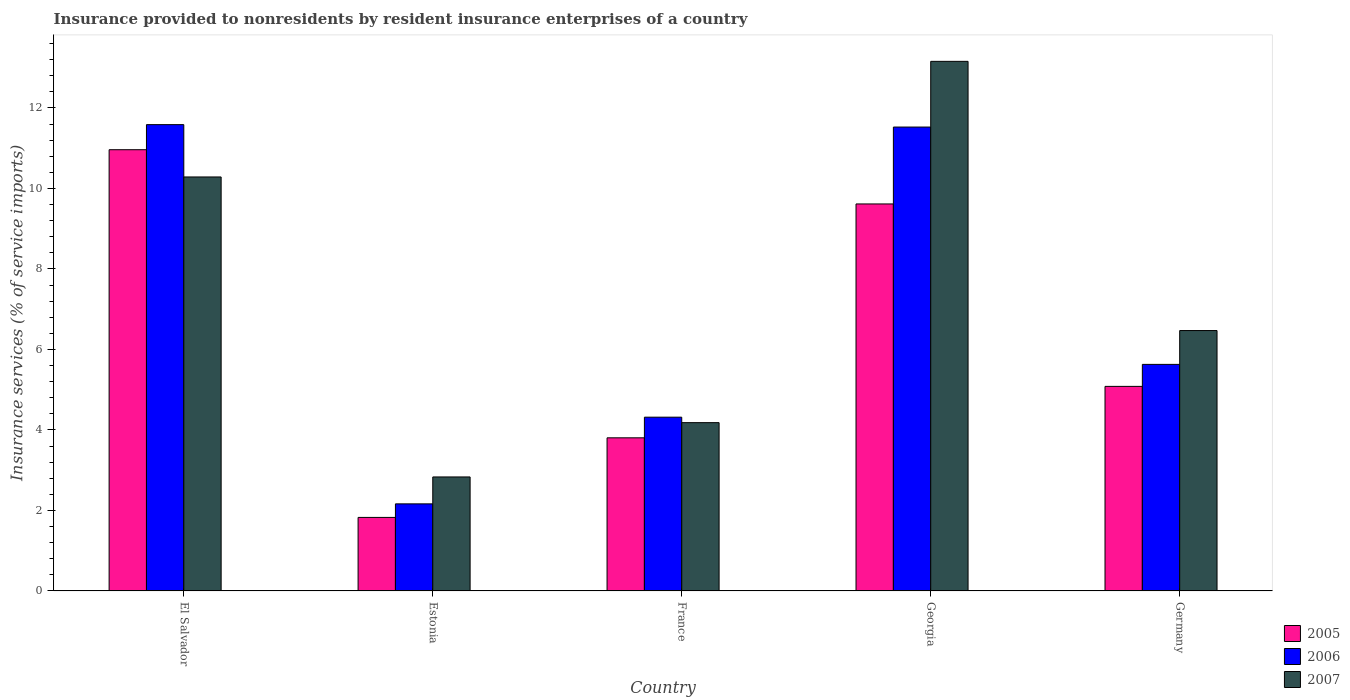Are the number of bars on each tick of the X-axis equal?
Offer a terse response. Yes. How many bars are there on the 4th tick from the left?
Your answer should be compact. 3. What is the label of the 4th group of bars from the left?
Your answer should be very brief. Georgia. What is the insurance provided to nonresidents in 2006 in Estonia?
Offer a very short reply. 2.16. Across all countries, what is the maximum insurance provided to nonresidents in 2006?
Provide a succinct answer. 11.59. Across all countries, what is the minimum insurance provided to nonresidents in 2005?
Your response must be concise. 1.83. In which country was the insurance provided to nonresidents in 2007 maximum?
Provide a succinct answer. Georgia. In which country was the insurance provided to nonresidents in 2006 minimum?
Your answer should be compact. Estonia. What is the total insurance provided to nonresidents in 2007 in the graph?
Provide a short and direct response. 36.93. What is the difference between the insurance provided to nonresidents in 2006 in Georgia and that in Germany?
Offer a terse response. 5.9. What is the difference between the insurance provided to nonresidents in 2007 in Estonia and the insurance provided to nonresidents in 2005 in Germany?
Give a very brief answer. -2.25. What is the average insurance provided to nonresidents in 2006 per country?
Ensure brevity in your answer.  7.04. What is the difference between the insurance provided to nonresidents of/in 2006 and insurance provided to nonresidents of/in 2005 in Germany?
Offer a terse response. 0.55. In how many countries, is the insurance provided to nonresidents in 2007 greater than 12.8 %?
Keep it short and to the point. 1. What is the ratio of the insurance provided to nonresidents in 2005 in Estonia to that in Germany?
Offer a terse response. 0.36. Is the insurance provided to nonresidents in 2005 in Georgia less than that in Germany?
Offer a very short reply. No. What is the difference between the highest and the second highest insurance provided to nonresidents in 2007?
Offer a very short reply. -2.87. What is the difference between the highest and the lowest insurance provided to nonresidents in 2007?
Your answer should be very brief. 10.32. Is the sum of the insurance provided to nonresidents in 2007 in Estonia and Georgia greater than the maximum insurance provided to nonresidents in 2006 across all countries?
Give a very brief answer. Yes. Is it the case that in every country, the sum of the insurance provided to nonresidents in 2007 and insurance provided to nonresidents in 2006 is greater than the insurance provided to nonresidents in 2005?
Provide a short and direct response. Yes. How many countries are there in the graph?
Your answer should be very brief. 5. What is the difference between two consecutive major ticks on the Y-axis?
Provide a short and direct response. 2. Are the values on the major ticks of Y-axis written in scientific E-notation?
Ensure brevity in your answer.  No. Does the graph contain any zero values?
Your answer should be compact. No. Where does the legend appear in the graph?
Provide a short and direct response. Bottom right. How many legend labels are there?
Make the answer very short. 3. What is the title of the graph?
Offer a very short reply. Insurance provided to nonresidents by resident insurance enterprises of a country. Does "1962" appear as one of the legend labels in the graph?
Make the answer very short. No. What is the label or title of the X-axis?
Your answer should be compact. Country. What is the label or title of the Y-axis?
Give a very brief answer. Insurance services (% of service imports). What is the Insurance services (% of service imports) of 2005 in El Salvador?
Offer a terse response. 10.96. What is the Insurance services (% of service imports) in 2006 in El Salvador?
Provide a succinct answer. 11.59. What is the Insurance services (% of service imports) of 2007 in El Salvador?
Ensure brevity in your answer.  10.29. What is the Insurance services (% of service imports) of 2005 in Estonia?
Provide a succinct answer. 1.83. What is the Insurance services (% of service imports) in 2006 in Estonia?
Offer a very short reply. 2.16. What is the Insurance services (% of service imports) in 2007 in Estonia?
Your answer should be compact. 2.83. What is the Insurance services (% of service imports) of 2005 in France?
Provide a short and direct response. 3.81. What is the Insurance services (% of service imports) of 2006 in France?
Your answer should be very brief. 4.32. What is the Insurance services (% of service imports) in 2007 in France?
Your response must be concise. 4.18. What is the Insurance services (% of service imports) in 2005 in Georgia?
Provide a succinct answer. 9.62. What is the Insurance services (% of service imports) of 2006 in Georgia?
Keep it short and to the point. 11.53. What is the Insurance services (% of service imports) of 2007 in Georgia?
Offer a very short reply. 13.16. What is the Insurance services (% of service imports) of 2005 in Germany?
Provide a short and direct response. 5.08. What is the Insurance services (% of service imports) of 2006 in Germany?
Provide a short and direct response. 5.63. What is the Insurance services (% of service imports) of 2007 in Germany?
Ensure brevity in your answer.  6.47. Across all countries, what is the maximum Insurance services (% of service imports) in 2005?
Provide a short and direct response. 10.96. Across all countries, what is the maximum Insurance services (% of service imports) in 2006?
Offer a very short reply. 11.59. Across all countries, what is the maximum Insurance services (% of service imports) of 2007?
Offer a very short reply. 13.16. Across all countries, what is the minimum Insurance services (% of service imports) of 2005?
Your response must be concise. 1.83. Across all countries, what is the minimum Insurance services (% of service imports) of 2006?
Your response must be concise. 2.16. Across all countries, what is the minimum Insurance services (% of service imports) of 2007?
Keep it short and to the point. 2.83. What is the total Insurance services (% of service imports) in 2005 in the graph?
Provide a succinct answer. 31.29. What is the total Insurance services (% of service imports) of 2006 in the graph?
Keep it short and to the point. 35.22. What is the total Insurance services (% of service imports) in 2007 in the graph?
Keep it short and to the point. 36.93. What is the difference between the Insurance services (% of service imports) in 2005 in El Salvador and that in Estonia?
Make the answer very short. 9.13. What is the difference between the Insurance services (% of service imports) of 2006 in El Salvador and that in Estonia?
Your answer should be compact. 9.42. What is the difference between the Insurance services (% of service imports) of 2007 in El Salvador and that in Estonia?
Provide a succinct answer. 7.45. What is the difference between the Insurance services (% of service imports) in 2005 in El Salvador and that in France?
Give a very brief answer. 7.16. What is the difference between the Insurance services (% of service imports) of 2006 in El Salvador and that in France?
Your answer should be very brief. 7.27. What is the difference between the Insurance services (% of service imports) of 2007 in El Salvador and that in France?
Your response must be concise. 6.1. What is the difference between the Insurance services (% of service imports) in 2005 in El Salvador and that in Georgia?
Offer a very short reply. 1.35. What is the difference between the Insurance services (% of service imports) of 2006 in El Salvador and that in Georgia?
Your answer should be compact. 0.06. What is the difference between the Insurance services (% of service imports) of 2007 in El Salvador and that in Georgia?
Keep it short and to the point. -2.87. What is the difference between the Insurance services (% of service imports) of 2005 in El Salvador and that in Germany?
Your answer should be very brief. 5.88. What is the difference between the Insurance services (% of service imports) in 2006 in El Salvador and that in Germany?
Keep it short and to the point. 5.96. What is the difference between the Insurance services (% of service imports) of 2007 in El Salvador and that in Germany?
Your response must be concise. 3.82. What is the difference between the Insurance services (% of service imports) in 2005 in Estonia and that in France?
Provide a short and direct response. -1.98. What is the difference between the Insurance services (% of service imports) in 2006 in Estonia and that in France?
Give a very brief answer. -2.15. What is the difference between the Insurance services (% of service imports) in 2007 in Estonia and that in France?
Make the answer very short. -1.35. What is the difference between the Insurance services (% of service imports) of 2005 in Estonia and that in Georgia?
Make the answer very short. -7.79. What is the difference between the Insurance services (% of service imports) in 2006 in Estonia and that in Georgia?
Make the answer very short. -9.36. What is the difference between the Insurance services (% of service imports) of 2007 in Estonia and that in Georgia?
Your response must be concise. -10.32. What is the difference between the Insurance services (% of service imports) in 2005 in Estonia and that in Germany?
Offer a very short reply. -3.25. What is the difference between the Insurance services (% of service imports) in 2006 in Estonia and that in Germany?
Your answer should be very brief. -3.47. What is the difference between the Insurance services (% of service imports) of 2007 in Estonia and that in Germany?
Keep it short and to the point. -3.64. What is the difference between the Insurance services (% of service imports) of 2005 in France and that in Georgia?
Offer a terse response. -5.81. What is the difference between the Insurance services (% of service imports) in 2006 in France and that in Georgia?
Keep it short and to the point. -7.21. What is the difference between the Insurance services (% of service imports) of 2007 in France and that in Georgia?
Make the answer very short. -8.98. What is the difference between the Insurance services (% of service imports) of 2005 in France and that in Germany?
Your answer should be very brief. -1.28. What is the difference between the Insurance services (% of service imports) in 2006 in France and that in Germany?
Provide a succinct answer. -1.31. What is the difference between the Insurance services (% of service imports) in 2007 in France and that in Germany?
Give a very brief answer. -2.29. What is the difference between the Insurance services (% of service imports) in 2005 in Georgia and that in Germany?
Provide a short and direct response. 4.53. What is the difference between the Insurance services (% of service imports) of 2006 in Georgia and that in Germany?
Keep it short and to the point. 5.9. What is the difference between the Insurance services (% of service imports) of 2007 in Georgia and that in Germany?
Provide a succinct answer. 6.69. What is the difference between the Insurance services (% of service imports) of 2005 in El Salvador and the Insurance services (% of service imports) of 2006 in Estonia?
Your answer should be very brief. 8.8. What is the difference between the Insurance services (% of service imports) in 2005 in El Salvador and the Insurance services (% of service imports) in 2007 in Estonia?
Offer a very short reply. 8.13. What is the difference between the Insurance services (% of service imports) of 2006 in El Salvador and the Insurance services (% of service imports) of 2007 in Estonia?
Keep it short and to the point. 8.75. What is the difference between the Insurance services (% of service imports) of 2005 in El Salvador and the Insurance services (% of service imports) of 2006 in France?
Ensure brevity in your answer.  6.64. What is the difference between the Insurance services (% of service imports) in 2005 in El Salvador and the Insurance services (% of service imports) in 2007 in France?
Offer a terse response. 6.78. What is the difference between the Insurance services (% of service imports) of 2006 in El Salvador and the Insurance services (% of service imports) of 2007 in France?
Provide a short and direct response. 7.4. What is the difference between the Insurance services (% of service imports) of 2005 in El Salvador and the Insurance services (% of service imports) of 2006 in Georgia?
Provide a succinct answer. -0.56. What is the difference between the Insurance services (% of service imports) in 2005 in El Salvador and the Insurance services (% of service imports) in 2007 in Georgia?
Offer a very short reply. -2.2. What is the difference between the Insurance services (% of service imports) of 2006 in El Salvador and the Insurance services (% of service imports) of 2007 in Georgia?
Your answer should be very brief. -1.57. What is the difference between the Insurance services (% of service imports) of 2005 in El Salvador and the Insurance services (% of service imports) of 2006 in Germany?
Offer a very short reply. 5.33. What is the difference between the Insurance services (% of service imports) of 2005 in El Salvador and the Insurance services (% of service imports) of 2007 in Germany?
Your answer should be compact. 4.49. What is the difference between the Insurance services (% of service imports) of 2006 in El Salvador and the Insurance services (% of service imports) of 2007 in Germany?
Ensure brevity in your answer.  5.12. What is the difference between the Insurance services (% of service imports) in 2005 in Estonia and the Insurance services (% of service imports) in 2006 in France?
Your response must be concise. -2.49. What is the difference between the Insurance services (% of service imports) of 2005 in Estonia and the Insurance services (% of service imports) of 2007 in France?
Offer a very short reply. -2.35. What is the difference between the Insurance services (% of service imports) of 2006 in Estonia and the Insurance services (% of service imports) of 2007 in France?
Provide a short and direct response. -2.02. What is the difference between the Insurance services (% of service imports) in 2005 in Estonia and the Insurance services (% of service imports) in 2006 in Georgia?
Offer a terse response. -9.7. What is the difference between the Insurance services (% of service imports) in 2005 in Estonia and the Insurance services (% of service imports) in 2007 in Georgia?
Keep it short and to the point. -11.33. What is the difference between the Insurance services (% of service imports) in 2006 in Estonia and the Insurance services (% of service imports) in 2007 in Georgia?
Your answer should be compact. -10.99. What is the difference between the Insurance services (% of service imports) in 2005 in Estonia and the Insurance services (% of service imports) in 2006 in Germany?
Your answer should be very brief. -3.8. What is the difference between the Insurance services (% of service imports) in 2005 in Estonia and the Insurance services (% of service imports) in 2007 in Germany?
Provide a succinct answer. -4.64. What is the difference between the Insurance services (% of service imports) in 2006 in Estonia and the Insurance services (% of service imports) in 2007 in Germany?
Your answer should be very brief. -4.31. What is the difference between the Insurance services (% of service imports) in 2005 in France and the Insurance services (% of service imports) in 2006 in Georgia?
Offer a terse response. -7.72. What is the difference between the Insurance services (% of service imports) of 2005 in France and the Insurance services (% of service imports) of 2007 in Georgia?
Provide a succinct answer. -9.35. What is the difference between the Insurance services (% of service imports) of 2006 in France and the Insurance services (% of service imports) of 2007 in Georgia?
Ensure brevity in your answer.  -8.84. What is the difference between the Insurance services (% of service imports) of 2005 in France and the Insurance services (% of service imports) of 2006 in Germany?
Keep it short and to the point. -1.82. What is the difference between the Insurance services (% of service imports) in 2005 in France and the Insurance services (% of service imports) in 2007 in Germany?
Offer a very short reply. -2.66. What is the difference between the Insurance services (% of service imports) in 2006 in France and the Insurance services (% of service imports) in 2007 in Germany?
Your answer should be compact. -2.15. What is the difference between the Insurance services (% of service imports) of 2005 in Georgia and the Insurance services (% of service imports) of 2006 in Germany?
Provide a succinct answer. 3.99. What is the difference between the Insurance services (% of service imports) in 2005 in Georgia and the Insurance services (% of service imports) in 2007 in Germany?
Your answer should be compact. 3.15. What is the difference between the Insurance services (% of service imports) of 2006 in Georgia and the Insurance services (% of service imports) of 2007 in Germany?
Give a very brief answer. 5.06. What is the average Insurance services (% of service imports) of 2005 per country?
Provide a short and direct response. 6.26. What is the average Insurance services (% of service imports) of 2006 per country?
Your response must be concise. 7.04. What is the average Insurance services (% of service imports) of 2007 per country?
Your answer should be very brief. 7.39. What is the difference between the Insurance services (% of service imports) of 2005 and Insurance services (% of service imports) of 2006 in El Salvador?
Give a very brief answer. -0.62. What is the difference between the Insurance services (% of service imports) of 2005 and Insurance services (% of service imports) of 2007 in El Salvador?
Offer a very short reply. 0.68. What is the difference between the Insurance services (% of service imports) in 2006 and Insurance services (% of service imports) in 2007 in El Salvador?
Provide a short and direct response. 1.3. What is the difference between the Insurance services (% of service imports) in 2005 and Insurance services (% of service imports) in 2006 in Estonia?
Provide a short and direct response. -0.34. What is the difference between the Insurance services (% of service imports) in 2005 and Insurance services (% of service imports) in 2007 in Estonia?
Your answer should be very brief. -1.01. What is the difference between the Insurance services (% of service imports) in 2006 and Insurance services (% of service imports) in 2007 in Estonia?
Your answer should be very brief. -0.67. What is the difference between the Insurance services (% of service imports) in 2005 and Insurance services (% of service imports) in 2006 in France?
Offer a terse response. -0.51. What is the difference between the Insurance services (% of service imports) in 2005 and Insurance services (% of service imports) in 2007 in France?
Your answer should be very brief. -0.38. What is the difference between the Insurance services (% of service imports) in 2006 and Insurance services (% of service imports) in 2007 in France?
Keep it short and to the point. 0.14. What is the difference between the Insurance services (% of service imports) of 2005 and Insurance services (% of service imports) of 2006 in Georgia?
Give a very brief answer. -1.91. What is the difference between the Insurance services (% of service imports) in 2005 and Insurance services (% of service imports) in 2007 in Georgia?
Provide a short and direct response. -3.54. What is the difference between the Insurance services (% of service imports) of 2006 and Insurance services (% of service imports) of 2007 in Georgia?
Make the answer very short. -1.63. What is the difference between the Insurance services (% of service imports) in 2005 and Insurance services (% of service imports) in 2006 in Germany?
Offer a terse response. -0.55. What is the difference between the Insurance services (% of service imports) in 2005 and Insurance services (% of service imports) in 2007 in Germany?
Give a very brief answer. -1.39. What is the difference between the Insurance services (% of service imports) of 2006 and Insurance services (% of service imports) of 2007 in Germany?
Provide a short and direct response. -0.84. What is the ratio of the Insurance services (% of service imports) of 2005 in El Salvador to that in Estonia?
Make the answer very short. 6. What is the ratio of the Insurance services (% of service imports) of 2006 in El Salvador to that in Estonia?
Your response must be concise. 5.35. What is the ratio of the Insurance services (% of service imports) in 2007 in El Salvador to that in Estonia?
Provide a succinct answer. 3.63. What is the ratio of the Insurance services (% of service imports) in 2005 in El Salvador to that in France?
Your answer should be very brief. 2.88. What is the ratio of the Insurance services (% of service imports) of 2006 in El Salvador to that in France?
Your response must be concise. 2.68. What is the ratio of the Insurance services (% of service imports) of 2007 in El Salvador to that in France?
Your response must be concise. 2.46. What is the ratio of the Insurance services (% of service imports) of 2005 in El Salvador to that in Georgia?
Your answer should be compact. 1.14. What is the ratio of the Insurance services (% of service imports) in 2006 in El Salvador to that in Georgia?
Your answer should be very brief. 1.01. What is the ratio of the Insurance services (% of service imports) of 2007 in El Salvador to that in Georgia?
Your answer should be very brief. 0.78. What is the ratio of the Insurance services (% of service imports) of 2005 in El Salvador to that in Germany?
Your answer should be compact. 2.16. What is the ratio of the Insurance services (% of service imports) in 2006 in El Salvador to that in Germany?
Provide a succinct answer. 2.06. What is the ratio of the Insurance services (% of service imports) in 2007 in El Salvador to that in Germany?
Give a very brief answer. 1.59. What is the ratio of the Insurance services (% of service imports) of 2005 in Estonia to that in France?
Your response must be concise. 0.48. What is the ratio of the Insurance services (% of service imports) in 2006 in Estonia to that in France?
Your answer should be very brief. 0.5. What is the ratio of the Insurance services (% of service imports) of 2007 in Estonia to that in France?
Offer a terse response. 0.68. What is the ratio of the Insurance services (% of service imports) in 2005 in Estonia to that in Georgia?
Ensure brevity in your answer.  0.19. What is the ratio of the Insurance services (% of service imports) in 2006 in Estonia to that in Georgia?
Offer a terse response. 0.19. What is the ratio of the Insurance services (% of service imports) of 2007 in Estonia to that in Georgia?
Keep it short and to the point. 0.22. What is the ratio of the Insurance services (% of service imports) in 2005 in Estonia to that in Germany?
Offer a very short reply. 0.36. What is the ratio of the Insurance services (% of service imports) in 2006 in Estonia to that in Germany?
Keep it short and to the point. 0.38. What is the ratio of the Insurance services (% of service imports) of 2007 in Estonia to that in Germany?
Offer a very short reply. 0.44. What is the ratio of the Insurance services (% of service imports) in 2005 in France to that in Georgia?
Ensure brevity in your answer.  0.4. What is the ratio of the Insurance services (% of service imports) of 2006 in France to that in Georgia?
Your response must be concise. 0.37. What is the ratio of the Insurance services (% of service imports) of 2007 in France to that in Georgia?
Keep it short and to the point. 0.32. What is the ratio of the Insurance services (% of service imports) in 2005 in France to that in Germany?
Your answer should be very brief. 0.75. What is the ratio of the Insurance services (% of service imports) of 2006 in France to that in Germany?
Your answer should be compact. 0.77. What is the ratio of the Insurance services (% of service imports) in 2007 in France to that in Germany?
Your response must be concise. 0.65. What is the ratio of the Insurance services (% of service imports) in 2005 in Georgia to that in Germany?
Offer a very short reply. 1.89. What is the ratio of the Insurance services (% of service imports) in 2006 in Georgia to that in Germany?
Make the answer very short. 2.05. What is the ratio of the Insurance services (% of service imports) in 2007 in Georgia to that in Germany?
Make the answer very short. 2.03. What is the difference between the highest and the second highest Insurance services (% of service imports) of 2005?
Your answer should be very brief. 1.35. What is the difference between the highest and the second highest Insurance services (% of service imports) of 2006?
Keep it short and to the point. 0.06. What is the difference between the highest and the second highest Insurance services (% of service imports) in 2007?
Make the answer very short. 2.87. What is the difference between the highest and the lowest Insurance services (% of service imports) in 2005?
Offer a very short reply. 9.13. What is the difference between the highest and the lowest Insurance services (% of service imports) of 2006?
Your response must be concise. 9.42. What is the difference between the highest and the lowest Insurance services (% of service imports) in 2007?
Your response must be concise. 10.32. 